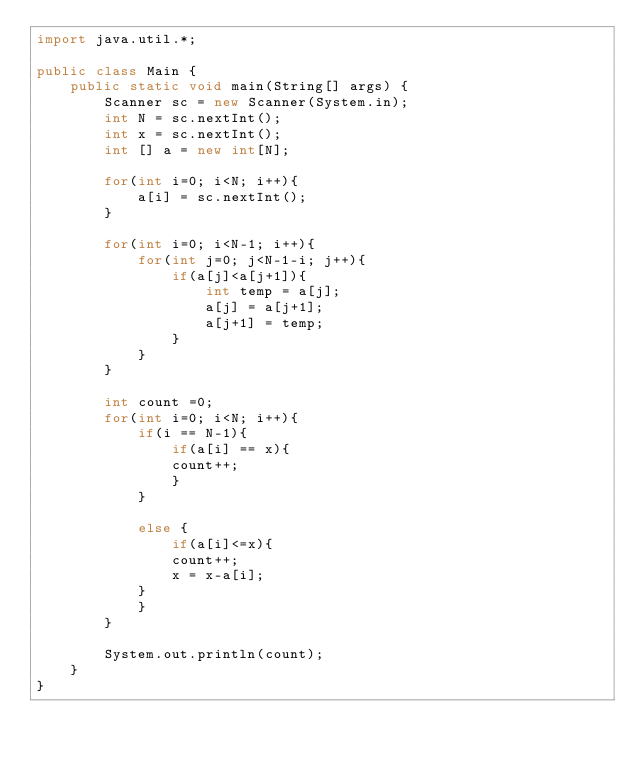Convert code to text. <code><loc_0><loc_0><loc_500><loc_500><_Java_>import java.util.*;

public class Main {
    public static void main(String[] args) {
        Scanner sc = new Scanner(System.in);
        int N = sc.nextInt();
        int x = sc.nextInt();
        int [] a = new int[N];
        
        for(int i=0; i<N; i++){
            a[i] = sc.nextInt();
        }
    
        for(int i=0; i<N-1; i++){
            for(int j=0; j<N-1-i; j++){
                if(a[j]<a[j+1]){
                    int temp = a[j];
                    a[j] = a[j+1];
                    a[j+1] = temp;
                }
            }
        }
            
        int count =0;
        for(int i=0; i<N; i++){
            if(i == N-1){
                if(a[i] == x){
                count++;
                }
            }
            
            else {
                if(a[i]<=x){
                count++;
                x = x-a[i];
            }
            }
        }
        
        System.out.println(count);
    }
}</code> 